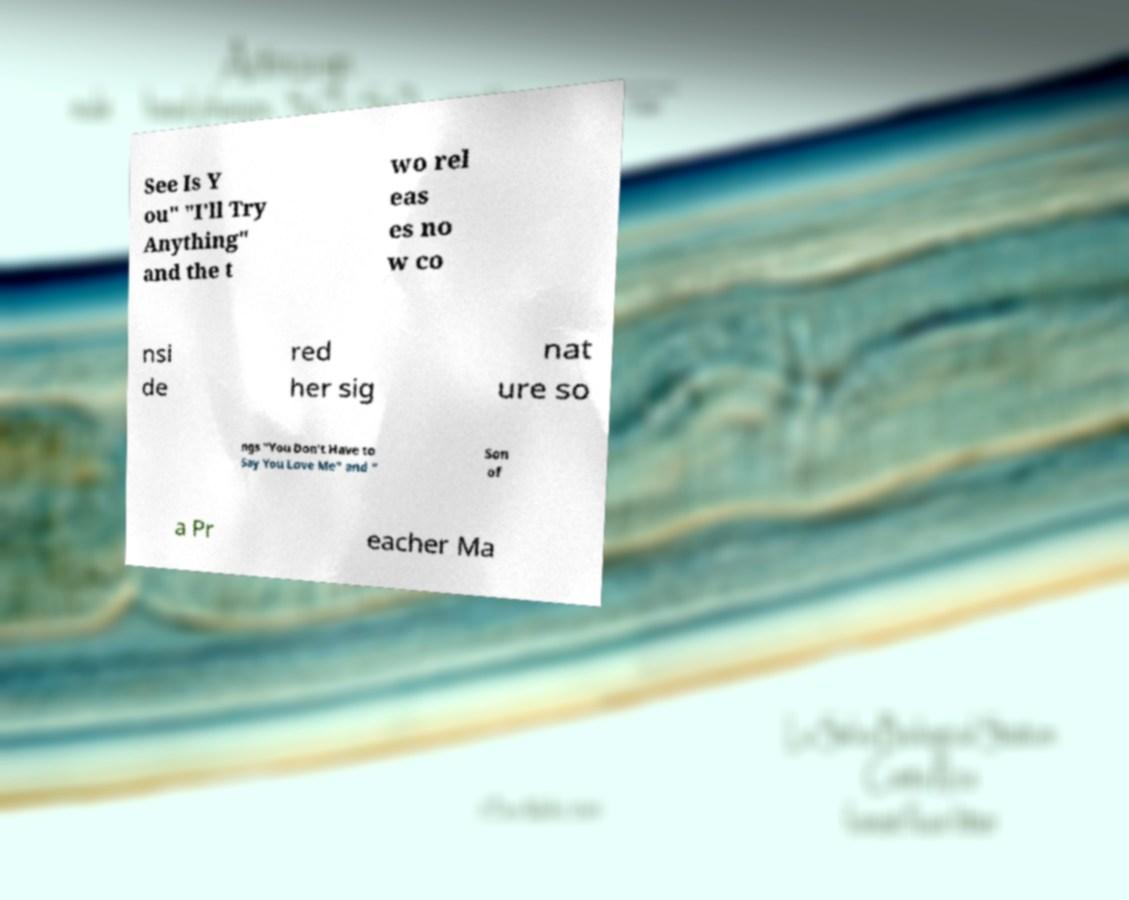Could you assist in decoding the text presented in this image and type it out clearly? See Is Y ou" "I'll Try Anything" and the t wo rel eas es no w co nsi de red her sig nat ure so ngs "You Don't Have to Say You Love Me" and " Son of a Pr eacher Ma 